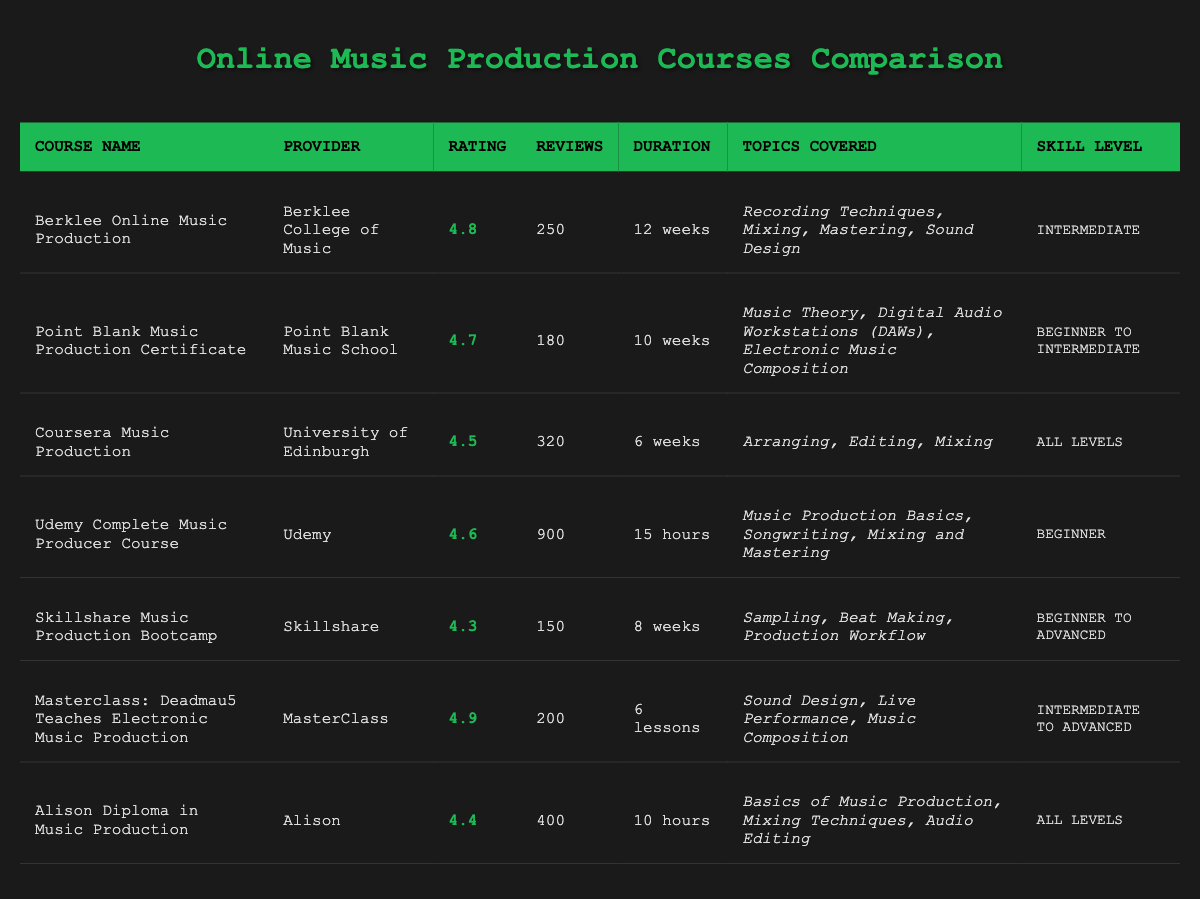What is the highest-rated course? To find the highest-rated course, I look at the "Rating" column and identify the maximum value. The rating 4.9 appears for the course "Masterclass: Deadmau5 Teaches Electronic Music Production."
Answer: Masterclass: Deadmau5 Teaches Electronic Music Production How many reviews does the Udemy course have? The "Udemy Complete Music Producer Course" has a specific entry in the "Reviews" column, which shows a total of 900 reviews.
Answer: 900 What is the average rating of all the courses? To calculate the average rating, I sum up all the ratings: 4.8 + 4.7 + 4.5 + 4.6 + 4.3 + 4.9 + 4.4 = 33.2. There are 7 courses, so I divide the sum by 7: 33.2 / 7 = 4.742857, which rounds to approximately 4.74.
Answer: 4.74 Is there a course for all skill levels? "Coursera Music Production" and "Alison Diploma in Music Production" both list "All Levels" in the skill level column, confirming the presence of courses suitable for all skill levels.
Answer: Yes How long does the Berklee course take? The "Course Duration" for "Berklee Online Music Production" is explicitly stated as "12 weeks."
Answer: 12 weeks Which course covers topics related to Electronic Music Composition? Checking the "Topics Covered" column for each course, the "Point Blank Music Production Certificate" specifically includes "Electronic Music Composition."
Answer: Point Blank Music Production Certificate What is the difference in the number of reviews between the highest and lowest reviewed courses? The highest reviewed course is "Udemy Complete Music Producer Course" with 900 reviews, while the lowest is the "Skillshare Music Production Bootcamp" with 150 reviews. The difference is 900 - 150 = 750.
Answer: 750 Is the Skillshare course rated above 4.5? The "Skillshare Music Production Bootcamp" has a rating of 4.3, which is below 4.5, thus the answer is "no."
Answer: No Which course has the shortest duration? Upon reviewing the "Course Duration" column, the "Udemy Complete Music Producer Course" has a duration of "15 hours," which is shorter than others listed in weeks.
Answer: Udemy Complete Music Producer Course 